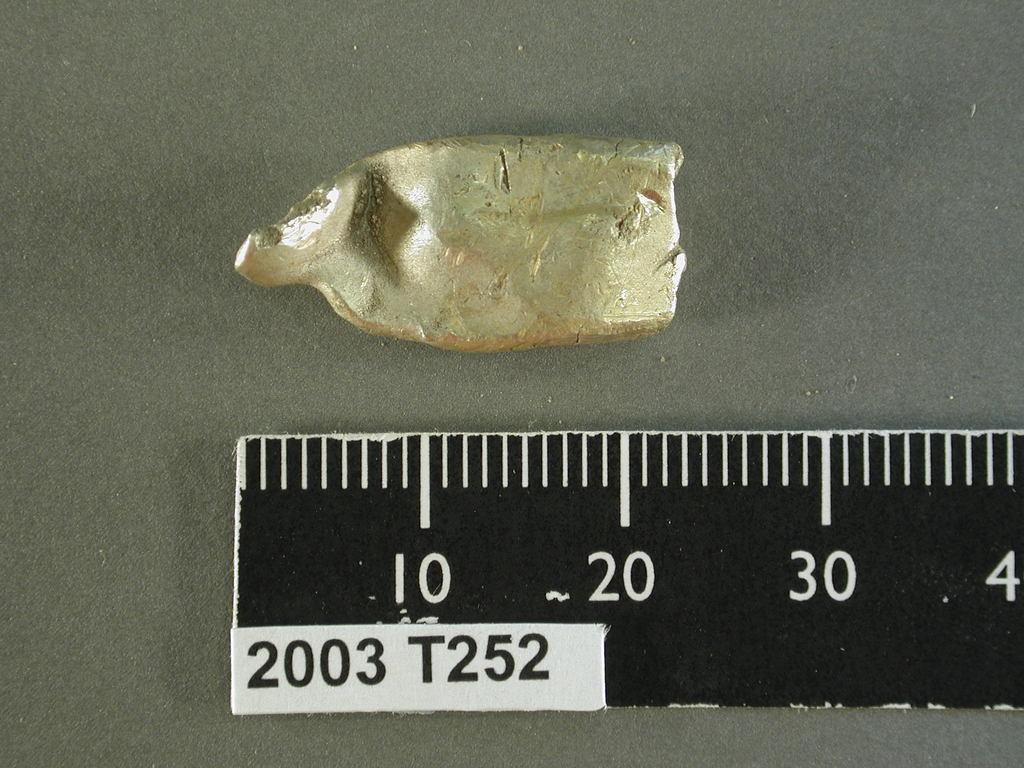<image>
Describe the image concisely. golden nugget next to black ruler with 2003 T252 on corner of it 